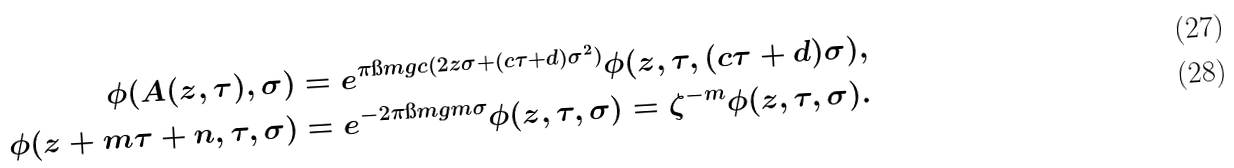Convert formula to latex. <formula><loc_0><loc_0><loc_500><loc_500>\phi ( A ( z , \tau ) , \sigma ) & = e ^ { \pi \i m g c ( 2 z \sigma + ( c \tau + d ) \sigma ^ { 2 } ) } \phi ( z , \tau , ( c \tau + d ) \sigma ) , \\ \phi ( z + m \tau + n , \tau , \sigma ) & = e ^ { - 2 \pi \i m g m \sigma } \phi ( z , \tau , \sigma ) = \zeta ^ { - m } \phi ( z , \tau , \sigma ) .</formula> 